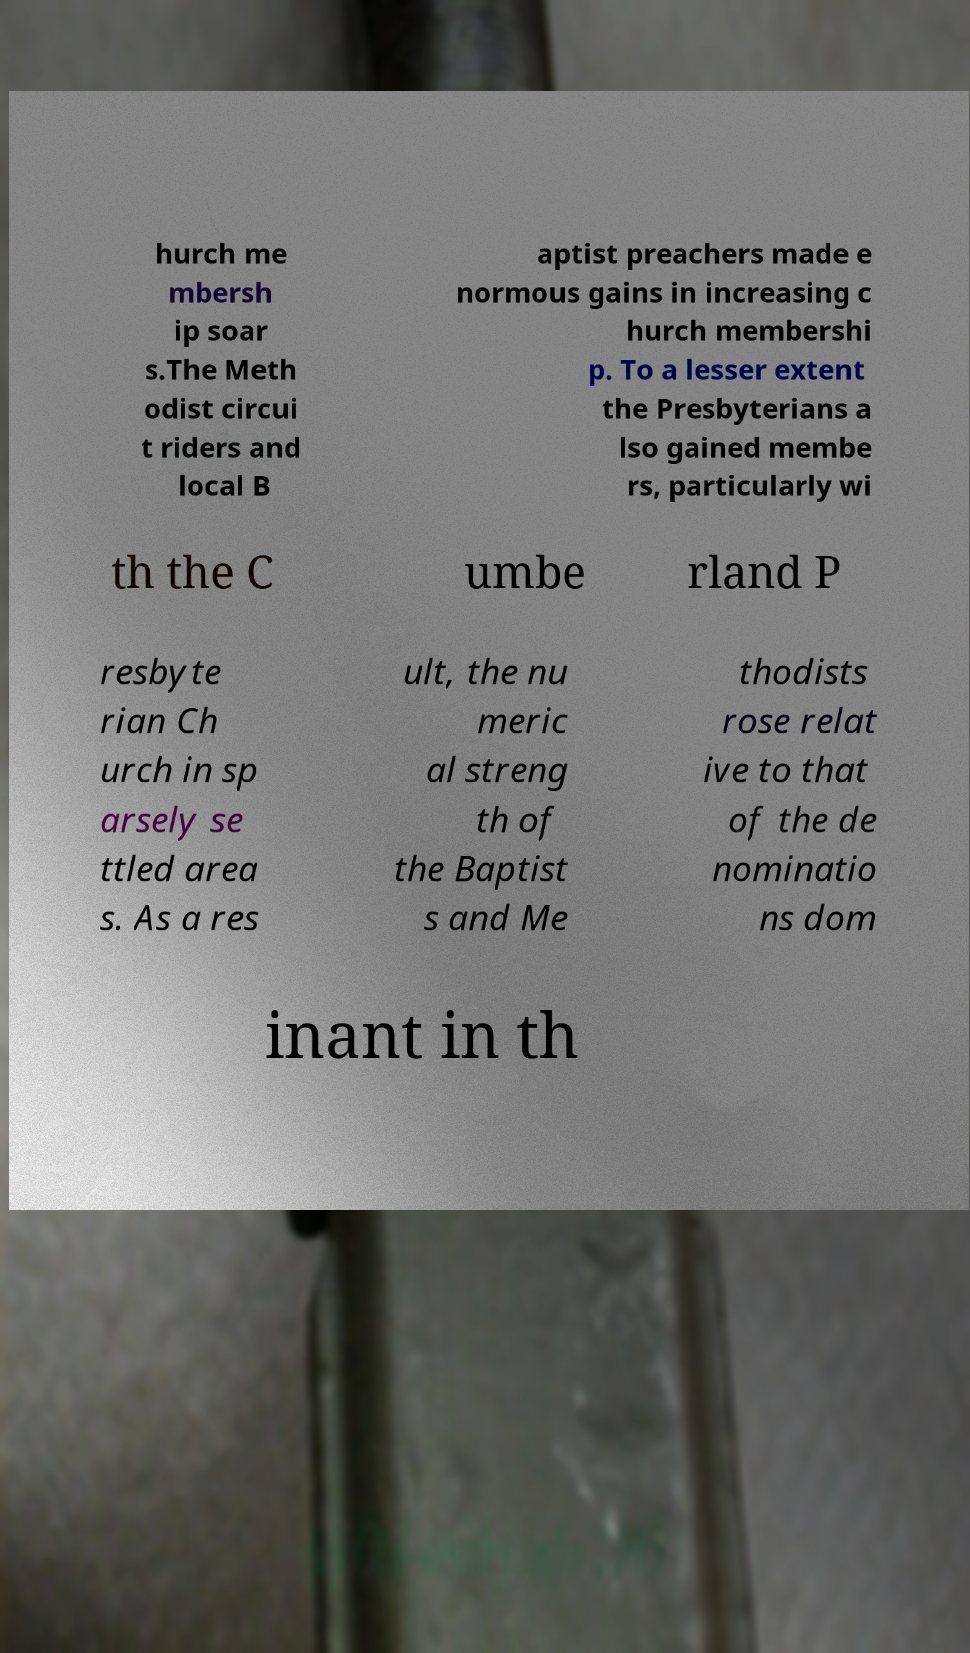I need the written content from this picture converted into text. Can you do that? hurch me mbersh ip soar s.The Meth odist circui t riders and local B aptist preachers made e normous gains in increasing c hurch membershi p. To a lesser extent the Presbyterians a lso gained membe rs, particularly wi th the C umbe rland P resbyte rian Ch urch in sp arsely se ttled area s. As a res ult, the nu meric al streng th of the Baptist s and Me thodists rose relat ive to that of the de nominatio ns dom inant in th 